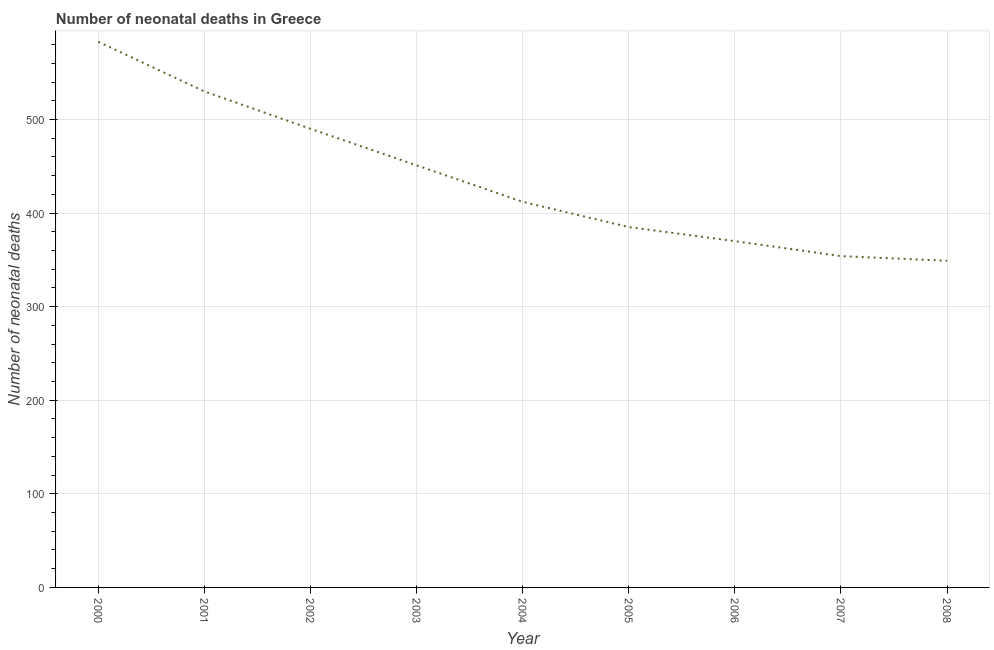What is the number of neonatal deaths in 2003?
Provide a short and direct response. 451. Across all years, what is the maximum number of neonatal deaths?
Offer a terse response. 583. Across all years, what is the minimum number of neonatal deaths?
Your answer should be very brief. 349. In which year was the number of neonatal deaths maximum?
Make the answer very short. 2000. What is the sum of the number of neonatal deaths?
Make the answer very short. 3924. What is the difference between the number of neonatal deaths in 2000 and 2002?
Provide a short and direct response. 93. What is the average number of neonatal deaths per year?
Provide a short and direct response. 436. What is the median number of neonatal deaths?
Provide a succinct answer. 412. What is the ratio of the number of neonatal deaths in 2001 to that in 2006?
Ensure brevity in your answer.  1.43. Is the sum of the number of neonatal deaths in 2004 and 2005 greater than the maximum number of neonatal deaths across all years?
Make the answer very short. Yes. What is the difference between the highest and the lowest number of neonatal deaths?
Keep it short and to the point. 234. How many years are there in the graph?
Your answer should be compact. 9. What is the difference between two consecutive major ticks on the Y-axis?
Provide a succinct answer. 100. Does the graph contain any zero values?
Provide a short and direct response. No. Does the graph contain grids?
Provide a succinct answer. Yes. What is the title of the graph?
Provide a succinct answer. Number of neonatal deaths in Greece. What is the label or title of the X-axis?
Your response must be concise. Year. What is the label or title of the Y-axis?
Provide a succinct answer. Number of neonatal deaths. What is the Number of neonatal deaths of 2000?
Keep it short and to the point. 583. What is the Number of neonatal deaths in 2001?
Give a very brief answer. 530. What is the Number of neonatal deaths in 2002?
Provide a short and direct response. 490. What is the Number of neonatal deaths in 2003?
Provide a succinct answer. 451. What is the Number of neonatal deaths in 2004?
Offer a very short reply. 412. What is the Number of neonatal deaths in 2005?
Give a very brief answer. 385. What is the Number of neonatal deaths of 2006?
Provide a short and direct response. 370. What is the Number of neonatal deaths of 2007?
Give a very brief answer. 354. What is the Number of neonatal deaths in 2008?
Give a very brief answer. 349. What is the difference between the Number of neonatal deaths in 2000 and 2002?
Give a very brief answer. 93. What is the difference between the Number of neonatal deaths in 2000 and 2003?
Your answer should be compact. 132. What is the difference between the Number of neonatal deaths in 2000 and 2004?
Your answer should be compact. 171. What is the difference between the Number of neonatal deaths in 2000 and 2005?
Provide a short and direct response. 198. What is the difference between the Number of neonatal deaths in 2000 and 2006?
Ensure brevity in your answer.  213. What is the difference between the Number of neonatal deaths in 2000 and 2007?
Give a very brief answer. 229. What is the difference between the Number of neonatal deaths in 2000 and 2008?
Your response must be concise. 234. What is the difference between the Number of neonatal deaths in 2001 and 2002?
Offer a terse response. 40. What is the difference between the Number of neonatal deaths in 2001 and 2003?
Provide a short and direct response. 79. What is the difference between the Number of neonatal deaths in 2001 and 2004?
Your answer should be compact. 118. What is the difference between the Number of neonatal deaths in 2001 and 2005?
Your answer should be compact. 145. What is the difference between the Number of neonatal deaths in 2001 and 2006?
Keep it short and to the point. 160. What is the difference between the Number of neonatal deaths in 2001 and 2007?
Provide a succinct answer. 176. What is the difference between the Number of neonatal deaths in 2001 and 2008?
Your response must be concise. 181. What is the difference between the Number of neonatal deaths in 2002 and 2003?
Your response must be concise. 39. What is the difference between the Number of neonatal deaths in 2002 and 2005?
Keep it short and to the point. 105. What is the difference between the Number of neonatal deaths in 2002 and 2006?
Ensure brevity in your answer.  120. What is the difference between the Number of neonatal deaths in 2002 and 2007?
Provide a short and direct response. 136. What is the difference between the Number of neonatal deaths in 2002 and 2008?
Provide a succinct answer. 141. What is the difference between the Number of neonatal deaths in 2003 and 2007?
Provide a short and direct response. 97. What is the difference between the Number of neonatal deaths in 2003 and 2008?
Your answer should be very brief. 102. What is the difference between the Number of neonatal deaths in 2004 and 2005?
Give a very brief answer. 27. What is the difference between the Number of neonatal deaths in 2004 and 2006?
Offer a very short reply. 42. What is the difference between the Number of neonatal deaths in 2004 and 2007?
Give a very brief answer. 58. What is the difference between the Number of neonatal deaths in 2005 and 2006?
Your answer should be compact. 15. What is the difference between the Number of neonatal deaths in 2005 and 2007?
Ensure brevity in your answer.  31. What is the difference between the Number of neonatal deaths in 2005 and 2008?
Your response must be concise. 36. What is the difference between the Number of neonatal deaths in 2007 and 2008?
Give a very brief answer. 5. What is the ratio of the Number of neonatal deaths in 2000 to that in 2002?
Your response must be concise. 1.19. What is the ratio of the Number of neonatal deaths in 2000 to that in 2003?
Your answer should be compact. 1.29. What is the ratio of the Number of neonatal deaths in 2000 to that in 2004?
Keep it short and to the point. 1.42. What is the ratio of the Number of neonatal deaths in 2000 to that in 2005?
Your answer should be very brief. 1.51. What is the ratio of the Number of neonatal deaths in 2000 to that in 2006?
Offer a very short reply. 1.58. What is the ratio of the Number of neonatal deaths in 2000 to that in 2007?
Your answer should be compact. 1.65. What is the ratio of the Number of neonatal deaths in 2000 to that in 2008?
Your answer should be very brief. 1.67. What is the ratio of the Number of neonatal deaths in 2001 to that in 2002?
Provide a succinct answer. 1.08. What is the ratio of the Number of neonatal deaths in 2001 to that in 2003?
Offer a very short reply. 1.18. What is the ratio of the Number of neonatal deaths in 2001 to that in 2004?
Offer a very short reply. 1.29. What is the ratio of the Number of neonatal deaths in 2001 to that in 2005?
Make the answer very short. 1.38. What is the ratio of the Number of neonatal deaths in 2001 to that in 2006?
Ensure brevity in your answer.  1.43. What is the ratio of the Number of neonatal deaths in 2001 to that in 2007?
Your answer should be very brief. 1.5. What is the ratio of the Number of neonatal deaths in 2001 to that in 2008?
Keep it short and to the point. 1.52. What is the ratio of the Number of neonatal deaths in 2002 to that in 2003?
Ensure brevity in your answer.  1.09. What is the ratio of the Number of neonatal deaths in 2002 to that in 2004?
Provide a short and direct response. 1.19. What is the ratio of the Number of neonatal deaths in 2002 to that in 2005?
Offer a very short reply. 1.27. What is the ratio of the Number of neonatal deaths in 2002 to that in 2006?
Offer a terse response. 1.32. What is the ratio of the Number of neonatal deaths in 2002 to that in 2007?
Keep it short and to the point. 1.38. What is the ratio of the Number of neonatal deaths in 2002 to that in 2008?
Make the answer very short. 1.4. What is the ratio of the Number of neonatal deaths in 2003 to that in 2004?
Keep it short and to the point. 1.09. What is the ratio of the Number of neonatal deaths in 2003 to that in 2005?
Give a very brief answer. 1.17. What is the ratio of the Number of neonatal deaths in 2003 to that in 2006?
Keep it short and to the point. 1.22. What is the ratio of the Number of neonatal deaths in 2003 to that in 2007?
Provide a short and direct response. 1.27. What is the ratio of the Number of neonatal deaths in 2003 to that in 2008?
Offer a terse response. 1.29. What is the ratio of the Number of neonatal deaths in 2004 to that in 2005?
Your response must be concise. 1.07. What is the ratio of the Number of neonatal deaths in 2004 to that in 2006?
Provide a short and direct response. 1.11. What is the ratio of the Number of neonatal deaths in 2004 to that in 2007?
Keep it short and to the point. 1.16. What is the ratio of the Number of neonatal deaths in 2004 to that in 2008?
Offer a terse response. 1.18. What is the ratio of the Number of neonatal deaths in 2005 to that in 2006?
Provide a short and direct response. 1.04. What is the ratio of the Number of neonatal deaths in 2005 to that in 2007?
Your answer should be compact. 1.09. What is the ratio of the Number of neonatal deaths in 2005 to that in 2008?
Give a very brief answer. 1.1. What is the ratio of the Number of neonatal deaths in 2006 to that in 2007?
Keep it short and to the point. 1.04. What is the ratio of the Number of neonatal deaths in 2006 to that in 2008?
Your answer should be compact. 1.06. 